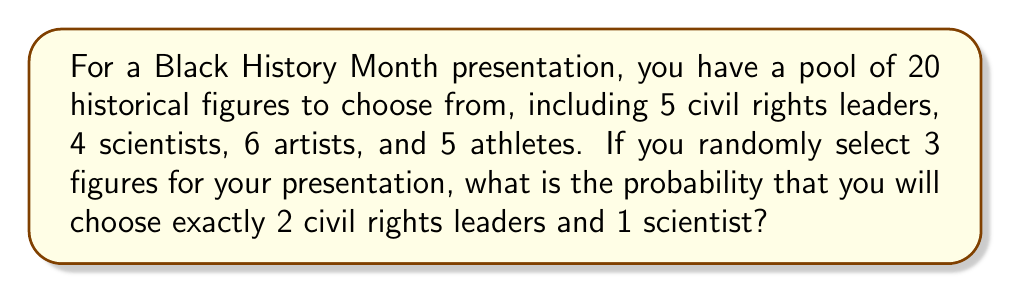Provide a solution to this math problem. Let's approach this step-by-step:

1. We need to use the concept of combinations to solve this problem.

2. First, let's calculate the number of ways to choose 2 civil rights leaders out of 5:
   $${5 \choose 2} = \frac{5!}{2!(5-2)!} = \frac{5 \cdot 4}{2 \cdot 1} = 10$$

3. Next, we calculate the number of ways to choose 1 scientist out of 4:
   $${4 \choose 1} = 4$$

4. The total number of ways to choose 2 civil rights leaders and 1 scientist is:
   $$10 \cdot 4 = 40$$

5. Now, we need to calculate the total number of ways to choose any 3 figures out of 20:
   $${20 \choose 3} = \frac{20!}{3!(20-3)!} = \frac{20 \cdot 19 \cdot 18}{3 \cdot 2 \cdot 1} = 1140$$

6. The probability is the number of favorable outcomes divided by the total number of possible outcomes:
   $$P(\text{2 civil rights leaders and 1 scientist}) = \frac{40}{1140} = \frac{1}{28.5} \approx 0.0351$$
Answer: $\frac{1}{28.5}$ or approximately $0.0351$ 